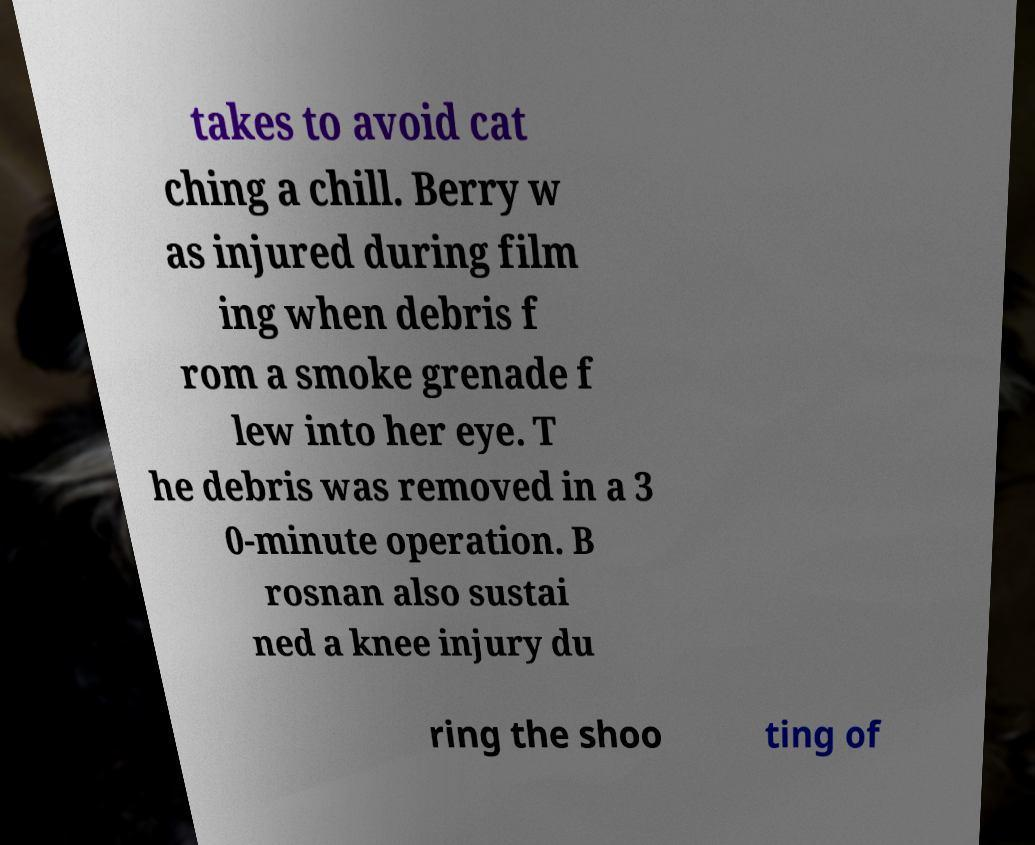What messages or text are displayed in this image? I need them in a readable, typed format. takes to avoid cat ching a chill. Berry w as injured during film ing when debris f rom a smoke grenade f lew into her eye. T he debris was removed in a 3 0-minute operation. B rosnan also sustai ned a knee injury du ring the shoo ting of 